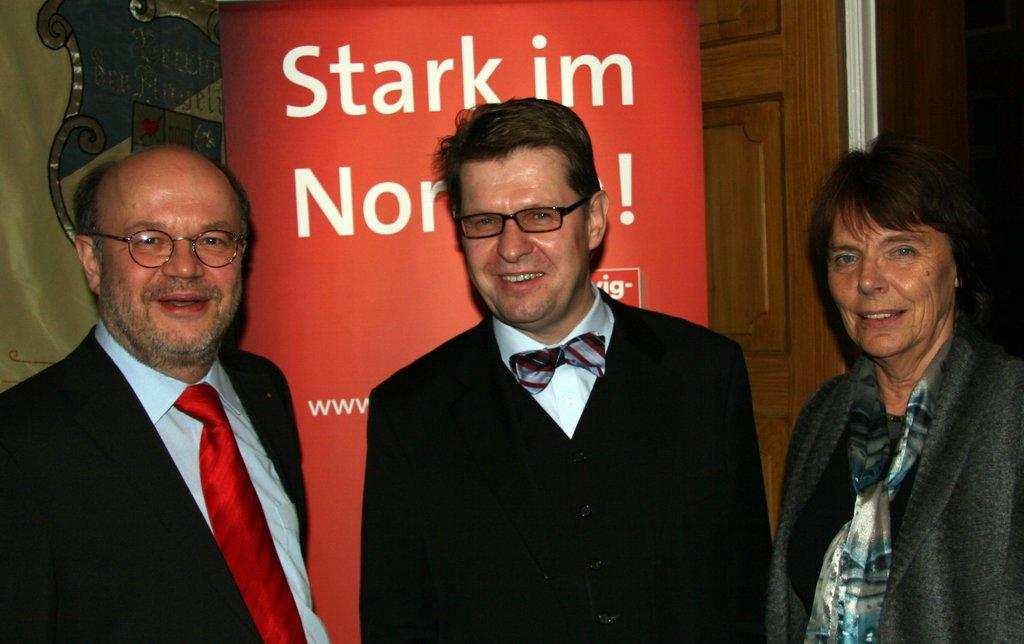How many people are in the image? There are three persons standing in the image. Can you describe the clothing of one of the persons? One person is wearing a black and white dress. What color is the board in the image? There is a board in red color in the image. What is the color of the door in the image? There is a door in brown color in the image. What type of teaching material is being used by the person in the image? There is no teaching material visible in the image. How many tickets are visible in the image? There are no tickets present in the image. 